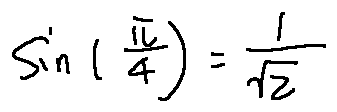Convert formula to latex. <formula><loc_0><loc_0><loc_500><loc_500>\sin ( \frac { \pi } { 4 } ) = \frac { 1 } { \sqrt { 2 } }</formula> 